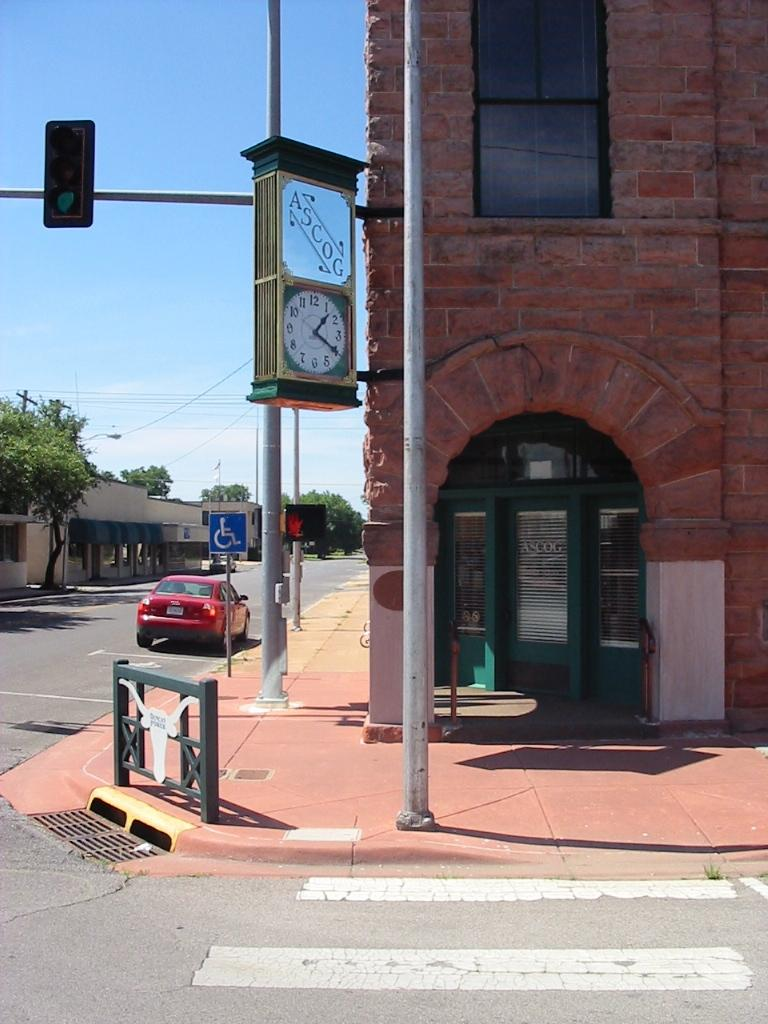Provide a one-sentence caption for the provided image. A street corner with the business ASCOG in an old multi story brick building. 